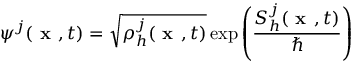Convert formula to latex. <formula><loc_0><loc_0><loc_500><loc_500>\psi ^ { j } ( x , t ) = \sqrt { \rho _ { h } ^ { j } ( x , t ) } \exp \left ( \frac { S _ { h } ^ { j } ( x , t ) } { } \right )</formula> 